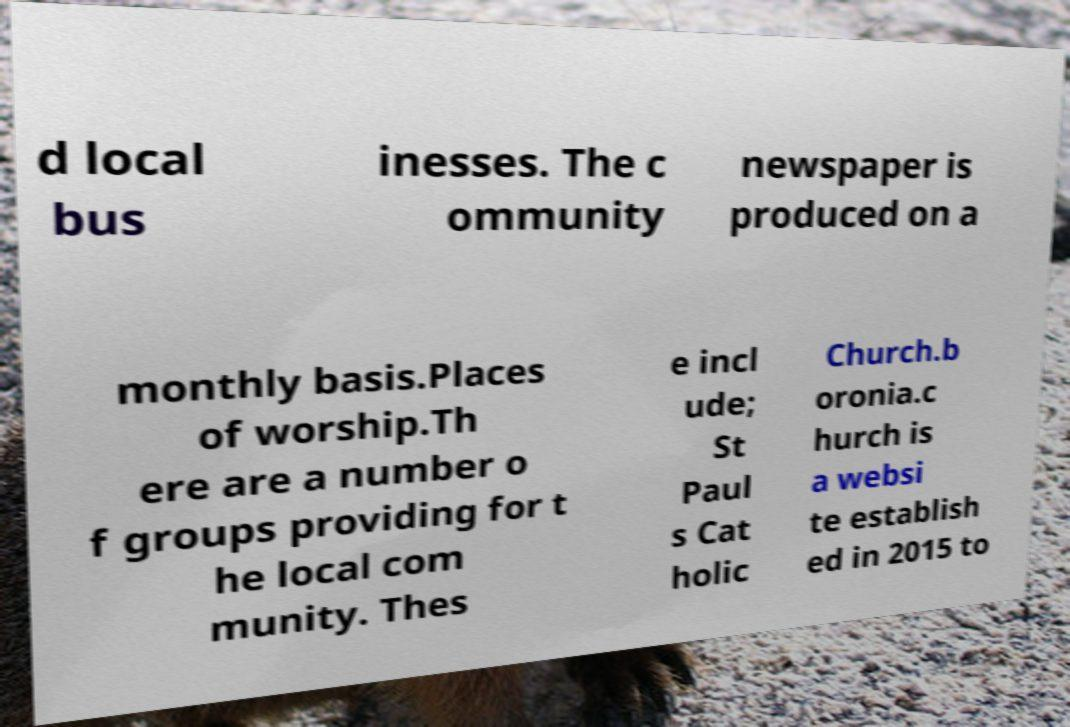There's text embedded in this image that I need extracted. Can you transcribe it verbatim? d local bus inesses. The c ommunity newspaper is produced on a monthly basis.Places of worship.Th ere are a number o f groups providing for t he local com munity. Thes e incl ude; St Paul s Cat holic Church.b oronia.c hurch is a websi te establish ed in 2015 to 